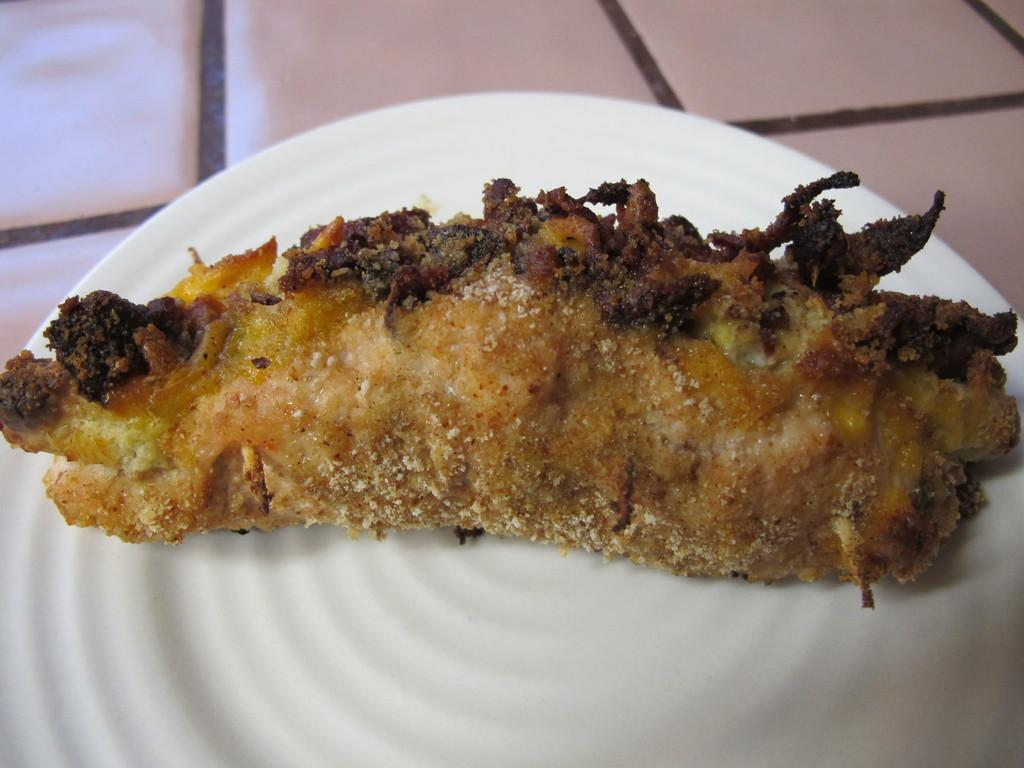What color is the plate that is visible in the image? The plate is white. What is on the plate in the image? The plate has food on it. Where is the plate located in the image? The plate is placed on a surface. What type of cherries are being used to treat the disease in the image? There is no mention of cherries or disease in the image; it only features a white plate with food on it. 